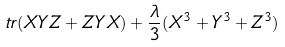Convert formula to latex. <formula><loc_0><loc_0><loc_500><loc_500>\ t r ( X Y Z + Z Y X ) + \frac { \lambda } { 3 } ( X ^ { 3 } + Y ^ { 3 } + Z ^ { 3 } )</formula> 